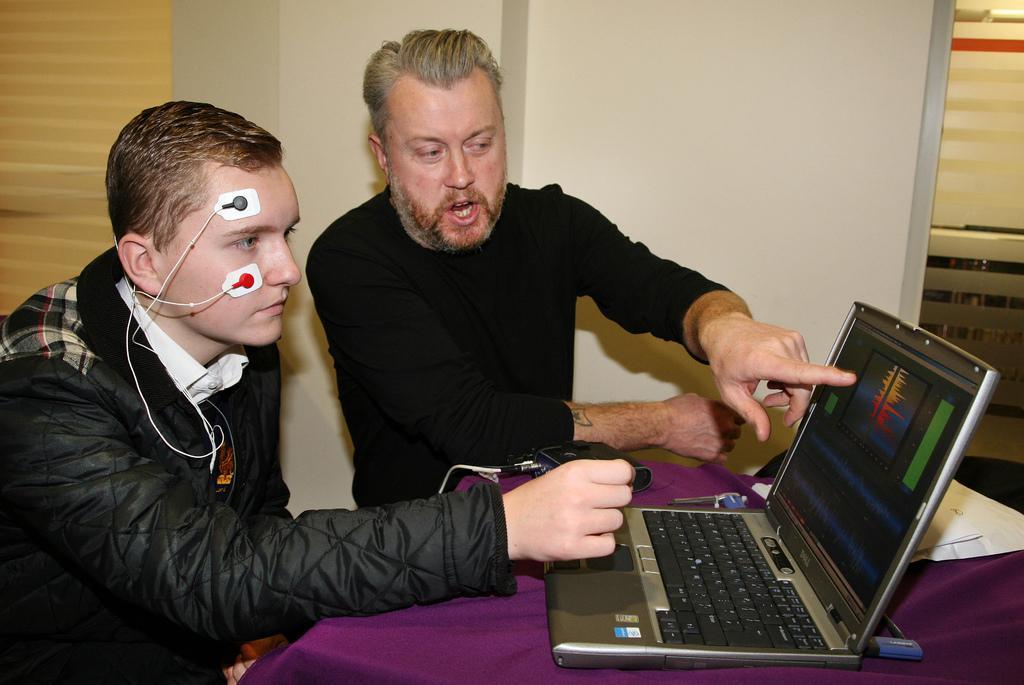In one or two sentences, can you explain what this image depicts? In this picture we can see there are two people sitting on the path and in front of the people we can see a cloth is covered an object. On the cloth there is a laptop and other things. Behind the people there is a wall. 